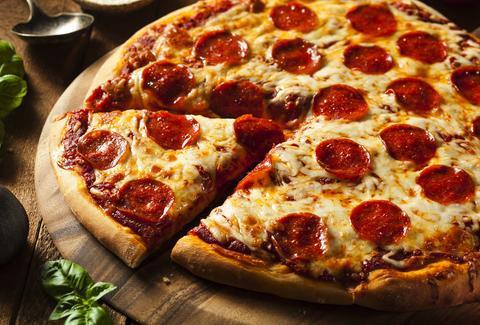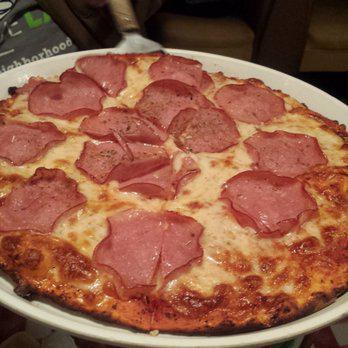The first image is the image on the left, the second image is the image on the right. Evaluate the accuracy of this statement regarding the images: "Two pizzas on white plates are baked and ready to eat, one plate sitting on a red checked tablecloth.". Is it true? Answer yes or no. No. The first image is the image on the left, the second image is the image on the right. Considering the images on both sides, is "The pizza in the image on the left is sitting on a red checked table cloth." valid? Answer yes or no. No. 